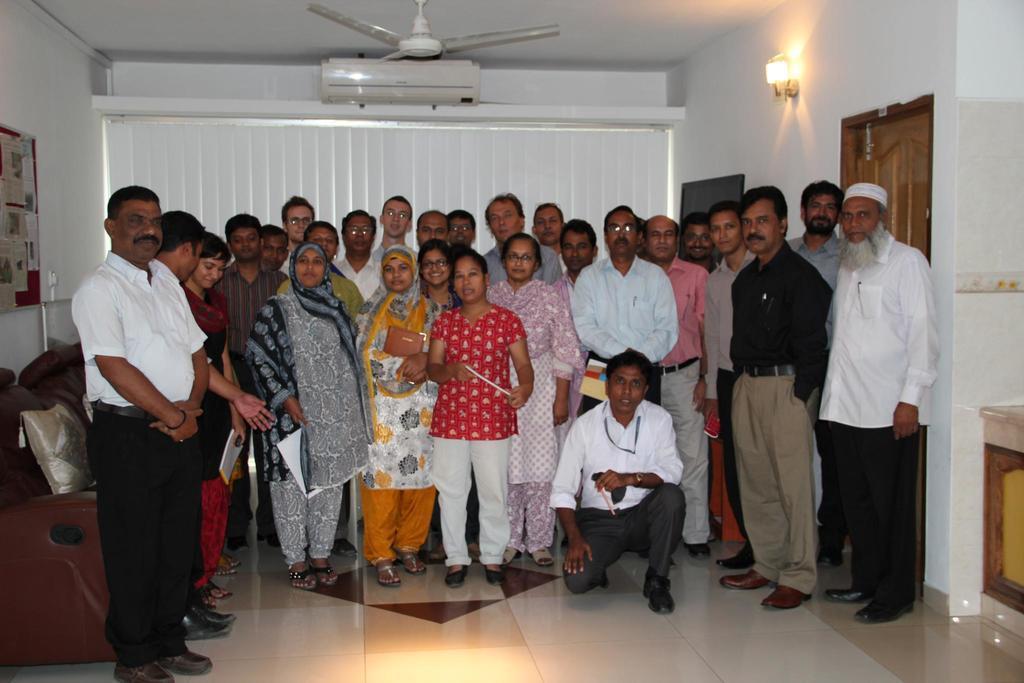In one or two sentences, can you explain what this image depicts? In this image people are standing on the floor. At the left side of the image there is a sofa. At the back side there are curtains and on top of it there is a Ac. On top of the roof there is a fan. At the left side of the image there is a wall and photo frames were attached to it. At the right side of the image there is a light and we can see a door at the right side of the image. 